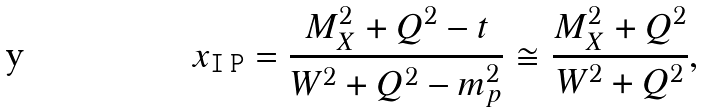<formula> <loc_0><loc_0><loc_500><loc_500>x _ { \tt I \, P } = \frac { M _ { X } ^ { 2 } + Q ^ { 2 } - t } { W ^ { 2 } + Q ^ { 2 } - m ^ { 2 } _ { p } } \cong \frac { M _ { X } ^ { 2 } + Q ^ { 2 } } { W ^ { 2 } + Q ^ { 2 } } ,</formula> 